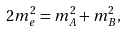Convert formula to latex. <formula><loc_0><loc_0><loc_500><loc_500>2 m _ { e } ^ { 2 } = m _ { A } ^ { 2 } + m _ { B } ^ { 2 } ,</formula> 